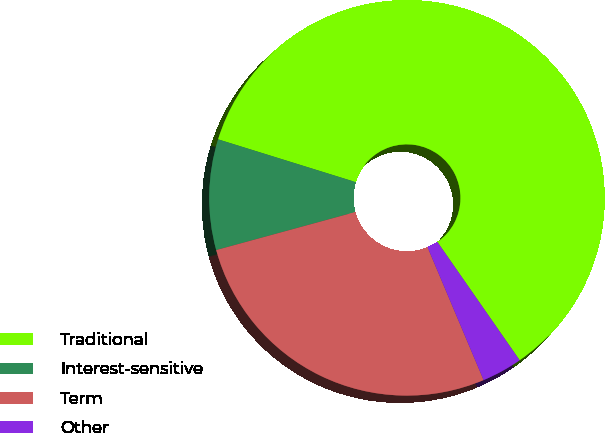<chart> <loc_0><loc_0><loc_500><loc_500><pie_chart><fcel>Traditional<fcel>Interest-sensitive<fcel>Term<fcel>Other<nl><fcel>60.53%<fcel>9.04%<fcel>27.11%<fcel>3.32%<nl></chart> 